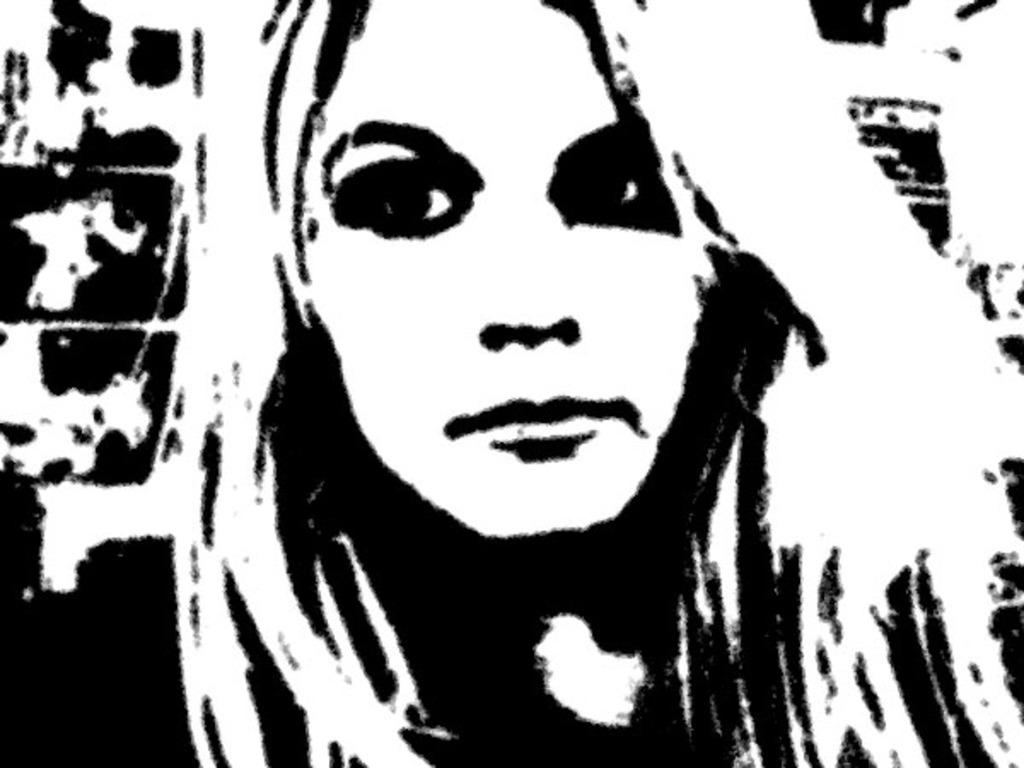What can be said about the appearance of the image? The image is edited and black and white. Can you describe the subject of the image? There is a woman in the image. What type of popcorn is being blown by the woman in the image? There is no popcorn or blowing action present in the image. Can you tell me how many grandmothers are in the image? There is no mention of a grandmother or any family members in the image; it only features a woman. 